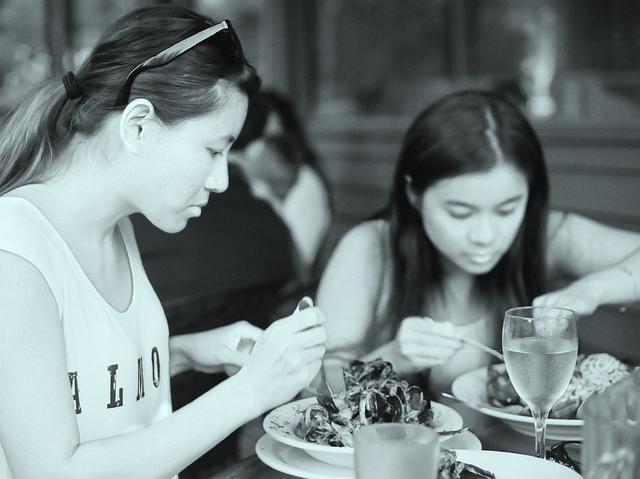Which girl has sunglasses on her head?
Concise answer only. Left. Is the water cold?
Quick response, please. Yes. Where are these people?
Give a very brief answer. Restaurant. 